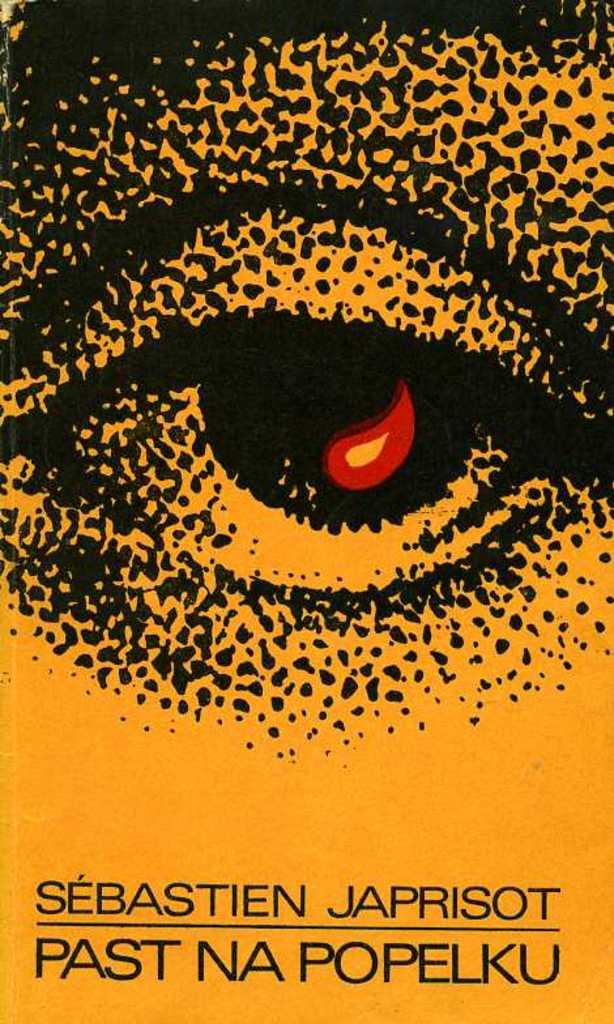<image>
Give a short and clear explanation of the subsequent image. Cover showing an eye and the name Sebastien Japrisot. 